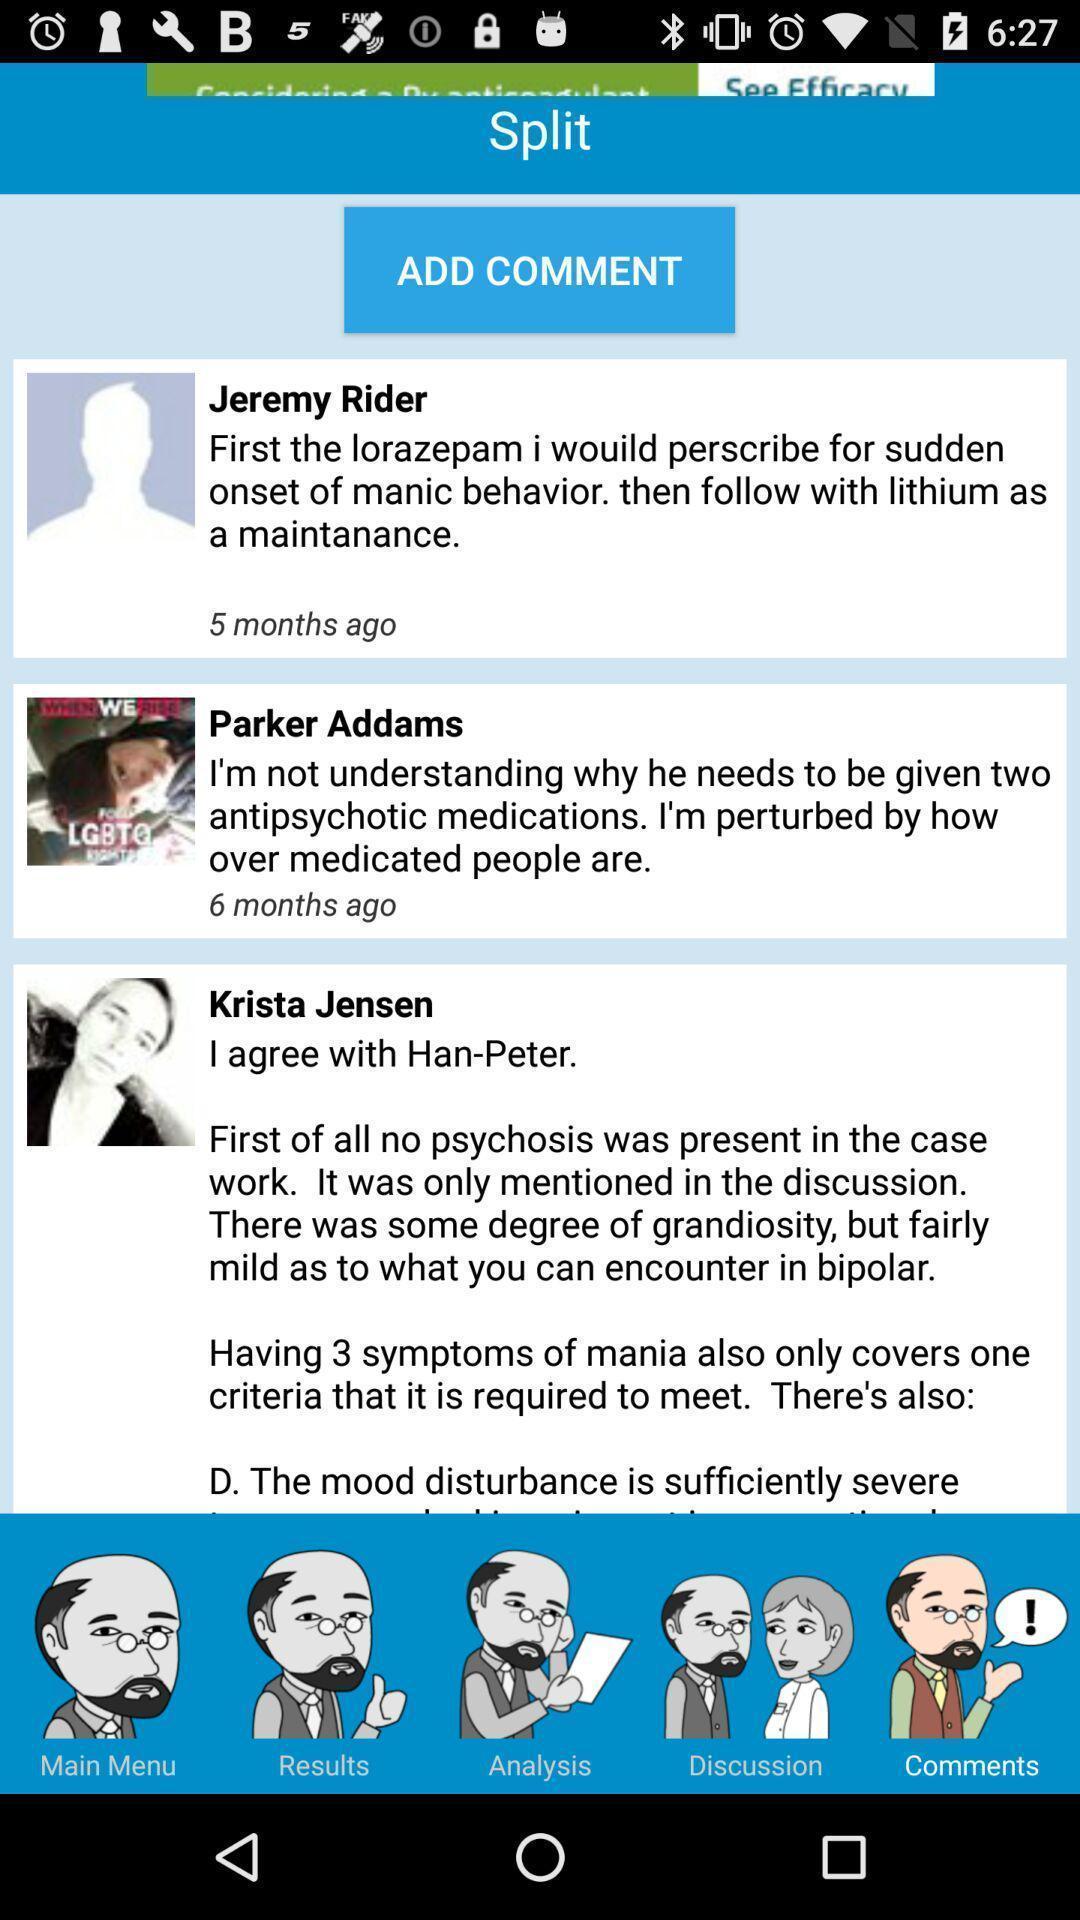What can you discern from this picture? Screen shows different persons comments. 